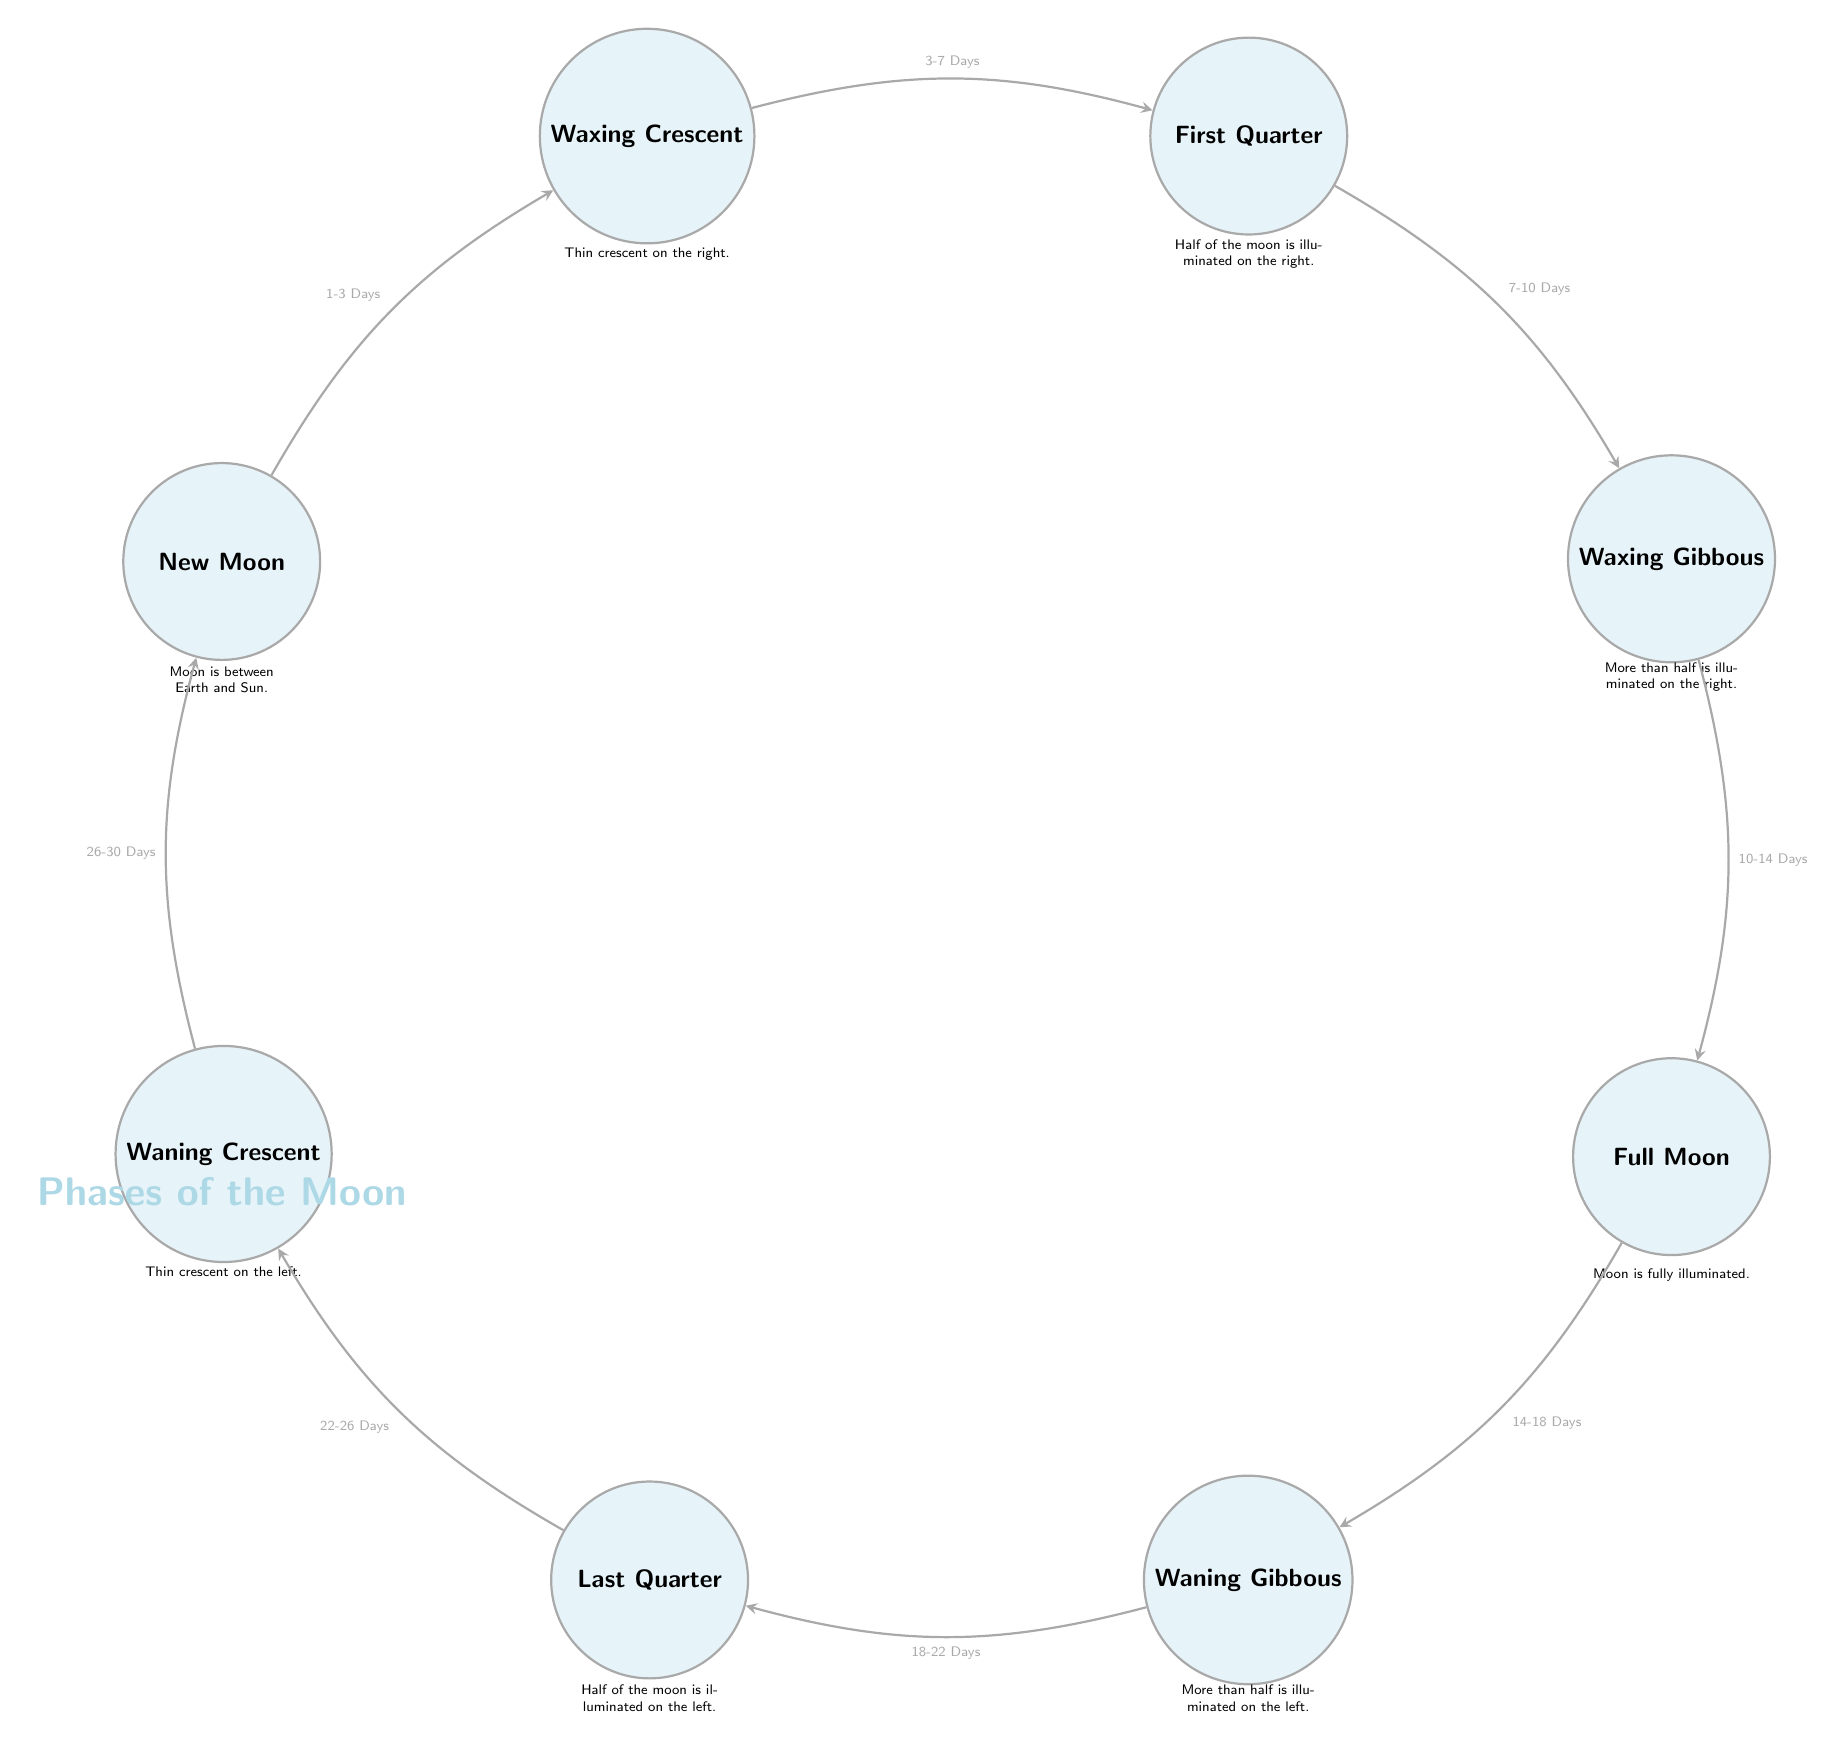What is the first phase of the Moon depicted in the diagram? The diagram shows "New Moon" as the first phase. By locating the first node in the diagram, which represents the starting point of the lunar phases, we can easily identify it as "New Moon."
Answer: New Moon What phase comes after the First Quarter? After identifying the "First Quarter," we can check the arrows leading from it. The next node that follows in the sequence is "Waxing Gibbous," which is positioned directly below right of "First Quarter."
Answer: Waxing Gibbous How many days does it take to transition from Full Moon to Waning Gibbous? By looking at the arrow between the two phases, the label indicates that the transition takes "14-18 Days." Thus, by identifying the start and end phases and reading the connecting arrow, we arrive at the required time duration.
Answer: 14-18 Days Which phase follows the Waxing Crescent? The diagram shows that the phase following "Waxing Crescent" is "First Quarter." By reviewing the nodes in sequence, we can trace the path from "Waxing Crescent" to the next adjacent node, which is "First Quarter."
Answer: First Quarter What is the illuminated appearance of the Moon during the Last Quarter? In the diagram, "Last Quarter" is described as "Half of the moon is illuminated on the left." Thus, by reading the description beneath the "Last Quarter" node, we get this specific detail.
Answer: Half of the moon is illuminated on the left How many total phases are represented in the diagram? Counting all distinct nodes from "New Moon" through "Waning Crescent," we see there are eight phases laid out in a circular arrangement. Thus, a complete count reveals there are 8 phases.
Answer: 8 What does the transition duration from Waning Gibbous to Last Quarter represent? The diagram connects "Waning Gibbous" to "Last Quarter," and the duration labeled on the arrow indicates "18-22 Days." By reading the label on the connecting arrow, we identify this time span.
Answer: 18-22 Days Which phase has a thin crescent on its left? The "Waning Crescent" phase is indicated to have a thin crescent on the left side as described in the diagram. We can pinpoint this by locating the specific node labeled "Waning Crescent."
Answer: Waning Crescent 